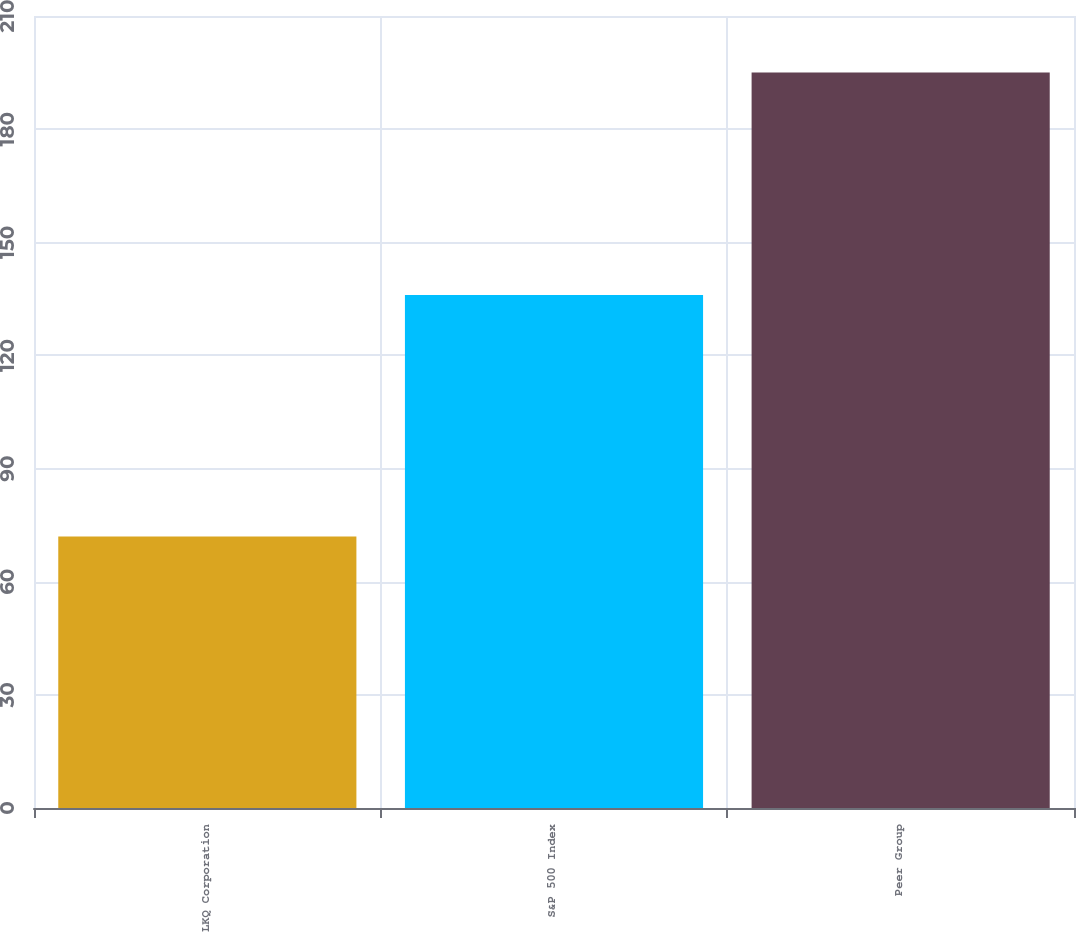<chart> <loc_0><loc_0><loc_500><loc_500><bar_chart><fcel>LKQ Corporation<fcel>S&P 500 Index<fcel>Peer Group<nl><fcel>72<fcel>136<fcel>195<nl></chart> 